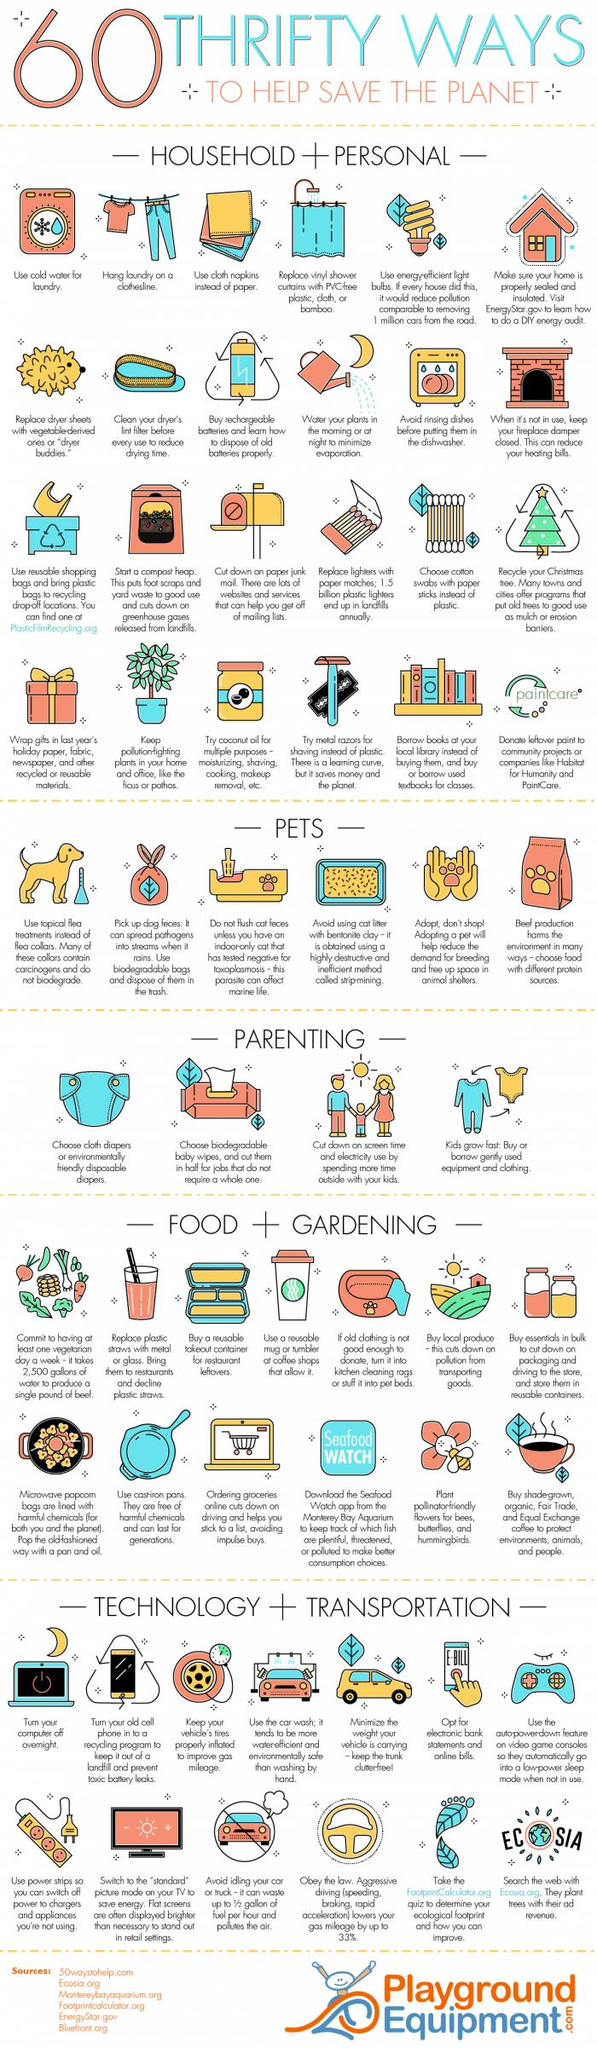Draw attention to some important aspects in this diagram. The use of cold water for laundry is indicated by the washing machine. Flea collars that contain carcinogens and do not biodegrade pose a significant health risk to pets and their handlers. Coconut oil can be used for a variety of purposes, including moisturizing, shaving, cooking, and makeup removal. Ecosia is a search engine that generates revenue through advertising, and uses a portion of that revenue to fund the planting of trees around the world. Gas mileage can be significantly improved by keeping the tires of your vehicle properly inflated. 